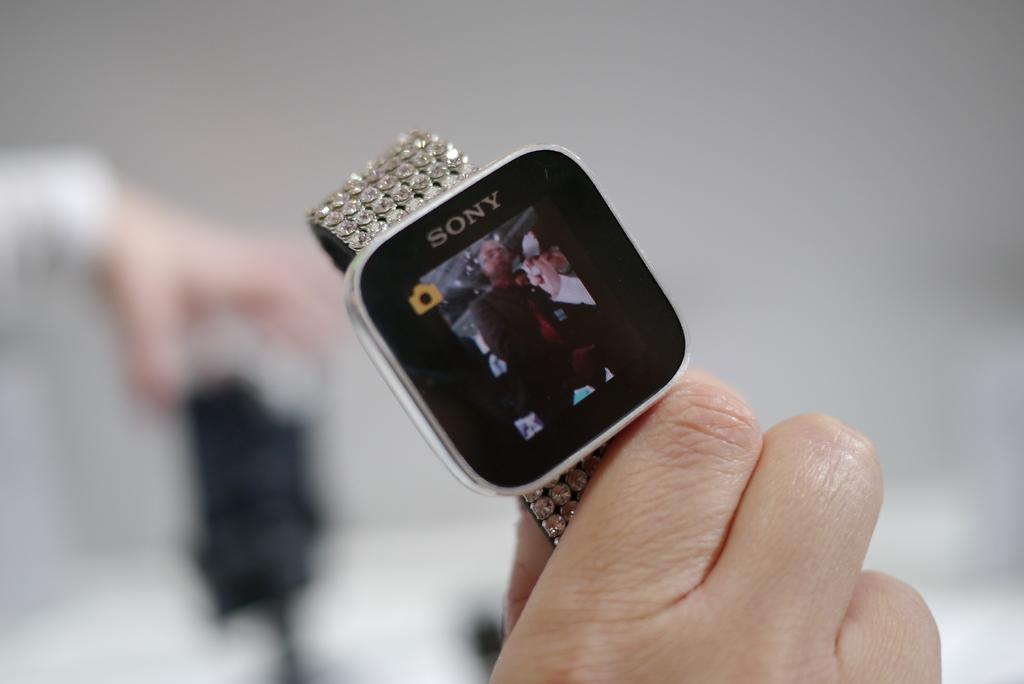<image>
Summarize the visual content of the image. A smart watch with a giant diamond band by Sony. 